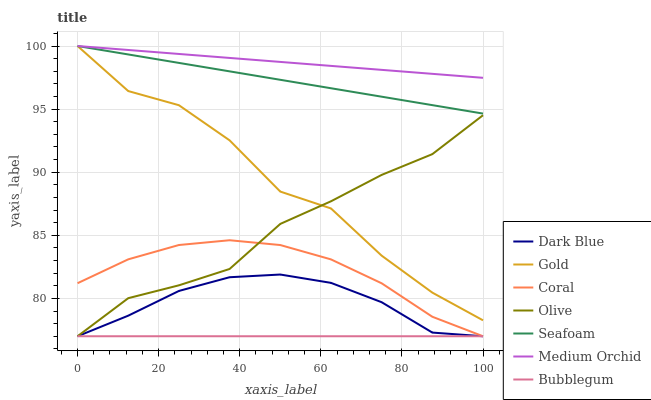Does Bubblegum have the minimum area under the curve?
Answer yes or no. Yes. Does Medium Orchid have the maximum area under the curve?
Answer yes or no. Yes. Does Coral have the minimum area under the curve?
Answer yes or no. No. Does Coral have the maximum area under the curve?
Answer yes or no. No. Is Medium Orchid the smoothest?
Answer yes or no. Yes. Is Gold the roughest?
Answer yes or no. Yes. Is Coral the smoothest?
Answer yes or no. No. Is Coral the roughest?
Answer yes or no. No. Does Coral have the lowest value?
Answer yes or no. Yes. Does Medium Orchid have the lowest value?
Answer yes or no. No. Does Seafoam have the highest value?
Answer yes or no. Yes. Does Coral have the highest value?
Answer yes or no. No. Is Coral less than Seafoam?
Answer yes or no. Yes. Is Seafoam greater than Olive?
Answer yes or no. Yes. Does Dark Blue intersect Bubblegum?
Answer yes or no. Yes. Is Dark Blue less than Bubblegum?
Answer yes or no. No. Is Dark Blue greater than Bubblegum?
Answer yes or no. No. Does Coral intersect Seafoam?
Answer yes or no. No. 